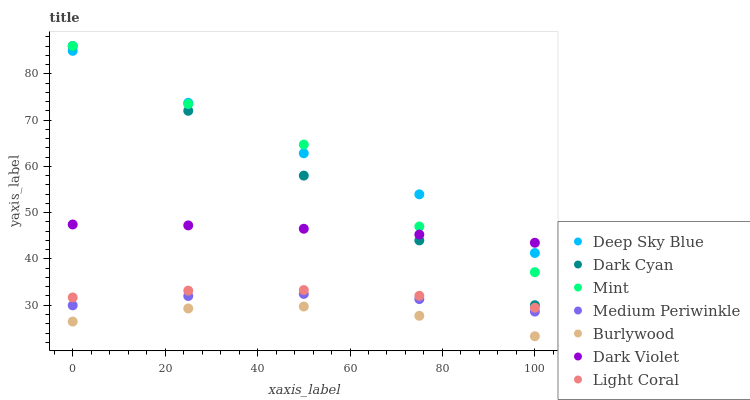Does Burlywood have the minimum area under the curve?
Answer yes or no. Yes. Does Deep Sky Blue have the maximum area under the curve?
Answer yes or no. Yes. Does Medium Periwinkle have the minimum area under the curve?
Answer yes or no. No. Does Medium Periwinkle have the maximum area under the curve?
Answer yes or no. No. Is Dark Cyan the smoothest?
Answer yes or no. Yes. Is Mint the roughest?
Answer yes or no. Yes. Is Medium Periwinkle the smoothest?
Answer yes or no. No. Is Medium Periwinkle the roughest?
Answer yes or no. No. Does Burlywood have the lowest value?
Answer yes or no. Yes. Does Medium Periwinkle have the lowest value?
Answer yes or no. No. Does Mint have the highest value?
Answer yes or no. Yes. Does Medium Periwinkle have the highest value?
Answer yes or no. No. Is Burlywood less than Dark Cyan?
Answer yes or no. Yes. Is Dark Violet greater than Medium Periwinkle?
Answer yes or no. Yes. Does Mint intersect Dark Cyan?
Answer yes or no. Yes. Is Mint less than Dark Cyan?
Answer yes or no. No. Is Mint greater than Dark Cyan?
Answer yes or no. No. Does Burlywood intersect Dark Cyan?
Answer yes or no. No. 